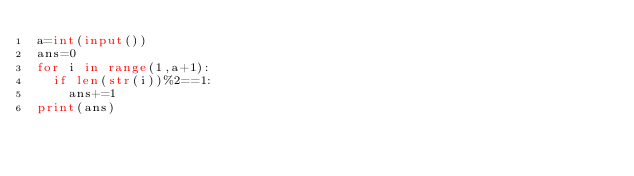<code> <loc_0><loc_0><loc_500><loc_500><_Python_>a=int(input())
ans=0
for i in range(1,a+1):
  if len(str(i))%2==1:
    ans+=1
print(ans)
</code> 